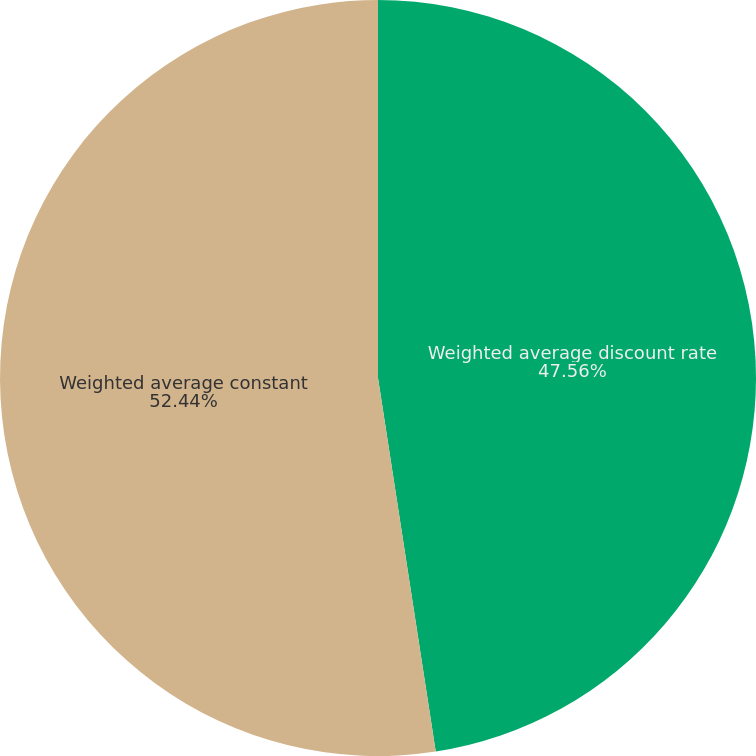Convert chart. <chart><loc_0><loc_0><loc_500><loc_500><pie_chart><fcel>Weighted average discount rate<fcel>Weighted average constant<nl><fcel>47.56%<fcel>52.44%<nl></chart> 